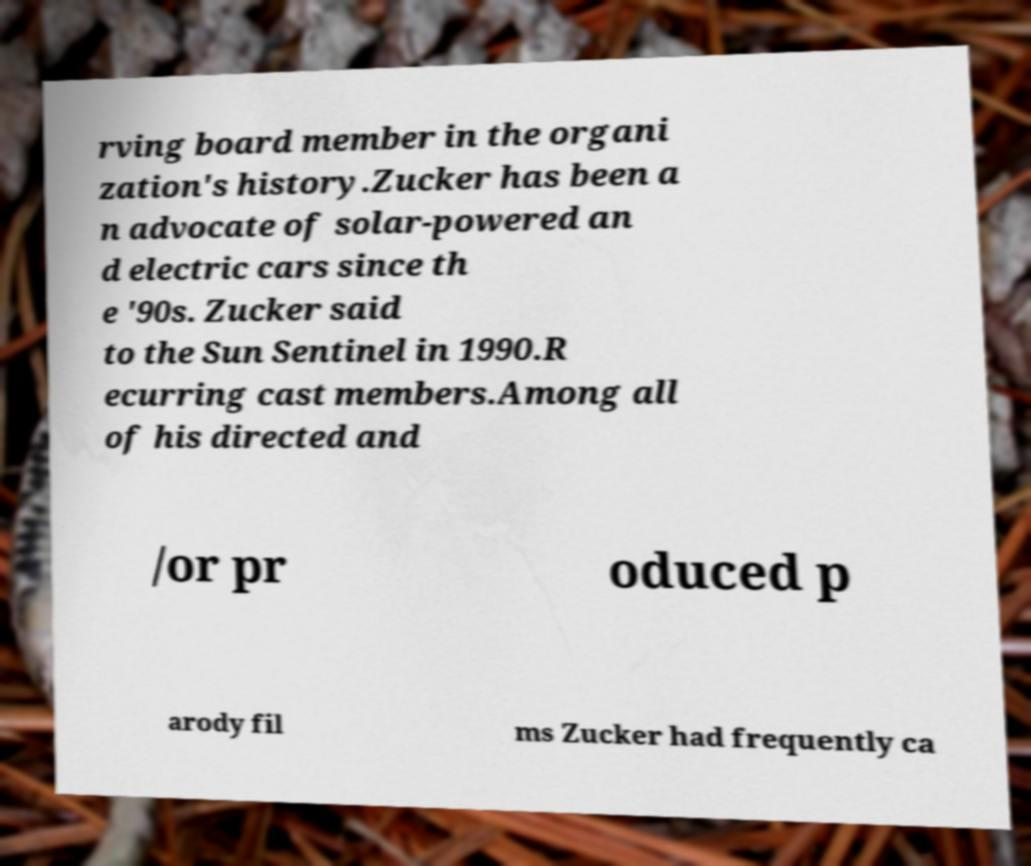Could you assist in decoding the text presented in this image and type it out clearly? rving board member in the organi zation's history.Zucker has been a n advocate of solar-powered an d electric cars since th e '90s. Zucker said to the Sun Sentinel in 1990.R ecurring cast members.Among all of his directed and /or pr oduced p arody fil ms Zucker had frequently ca 